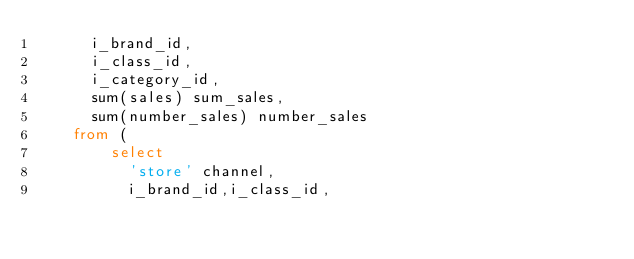<code> <loc_0><loc_0><loc_500><loc_500><_SQL_>      i_brand_id,
      i_class_id,
      i_category_id,
      sum(sales) sum_sales,
      sum(number_sales) number_sales
    from (
        select
          'store' channel,
          i_brand_id,i_class_id,</code> 